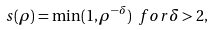<formula> <loc_0><loc_0><loc_500><loc_500>s ( \rho ) = \min ( 1 , \rho ^ { - \delta } ) \ f o r \delta > 2 ,</formula> 